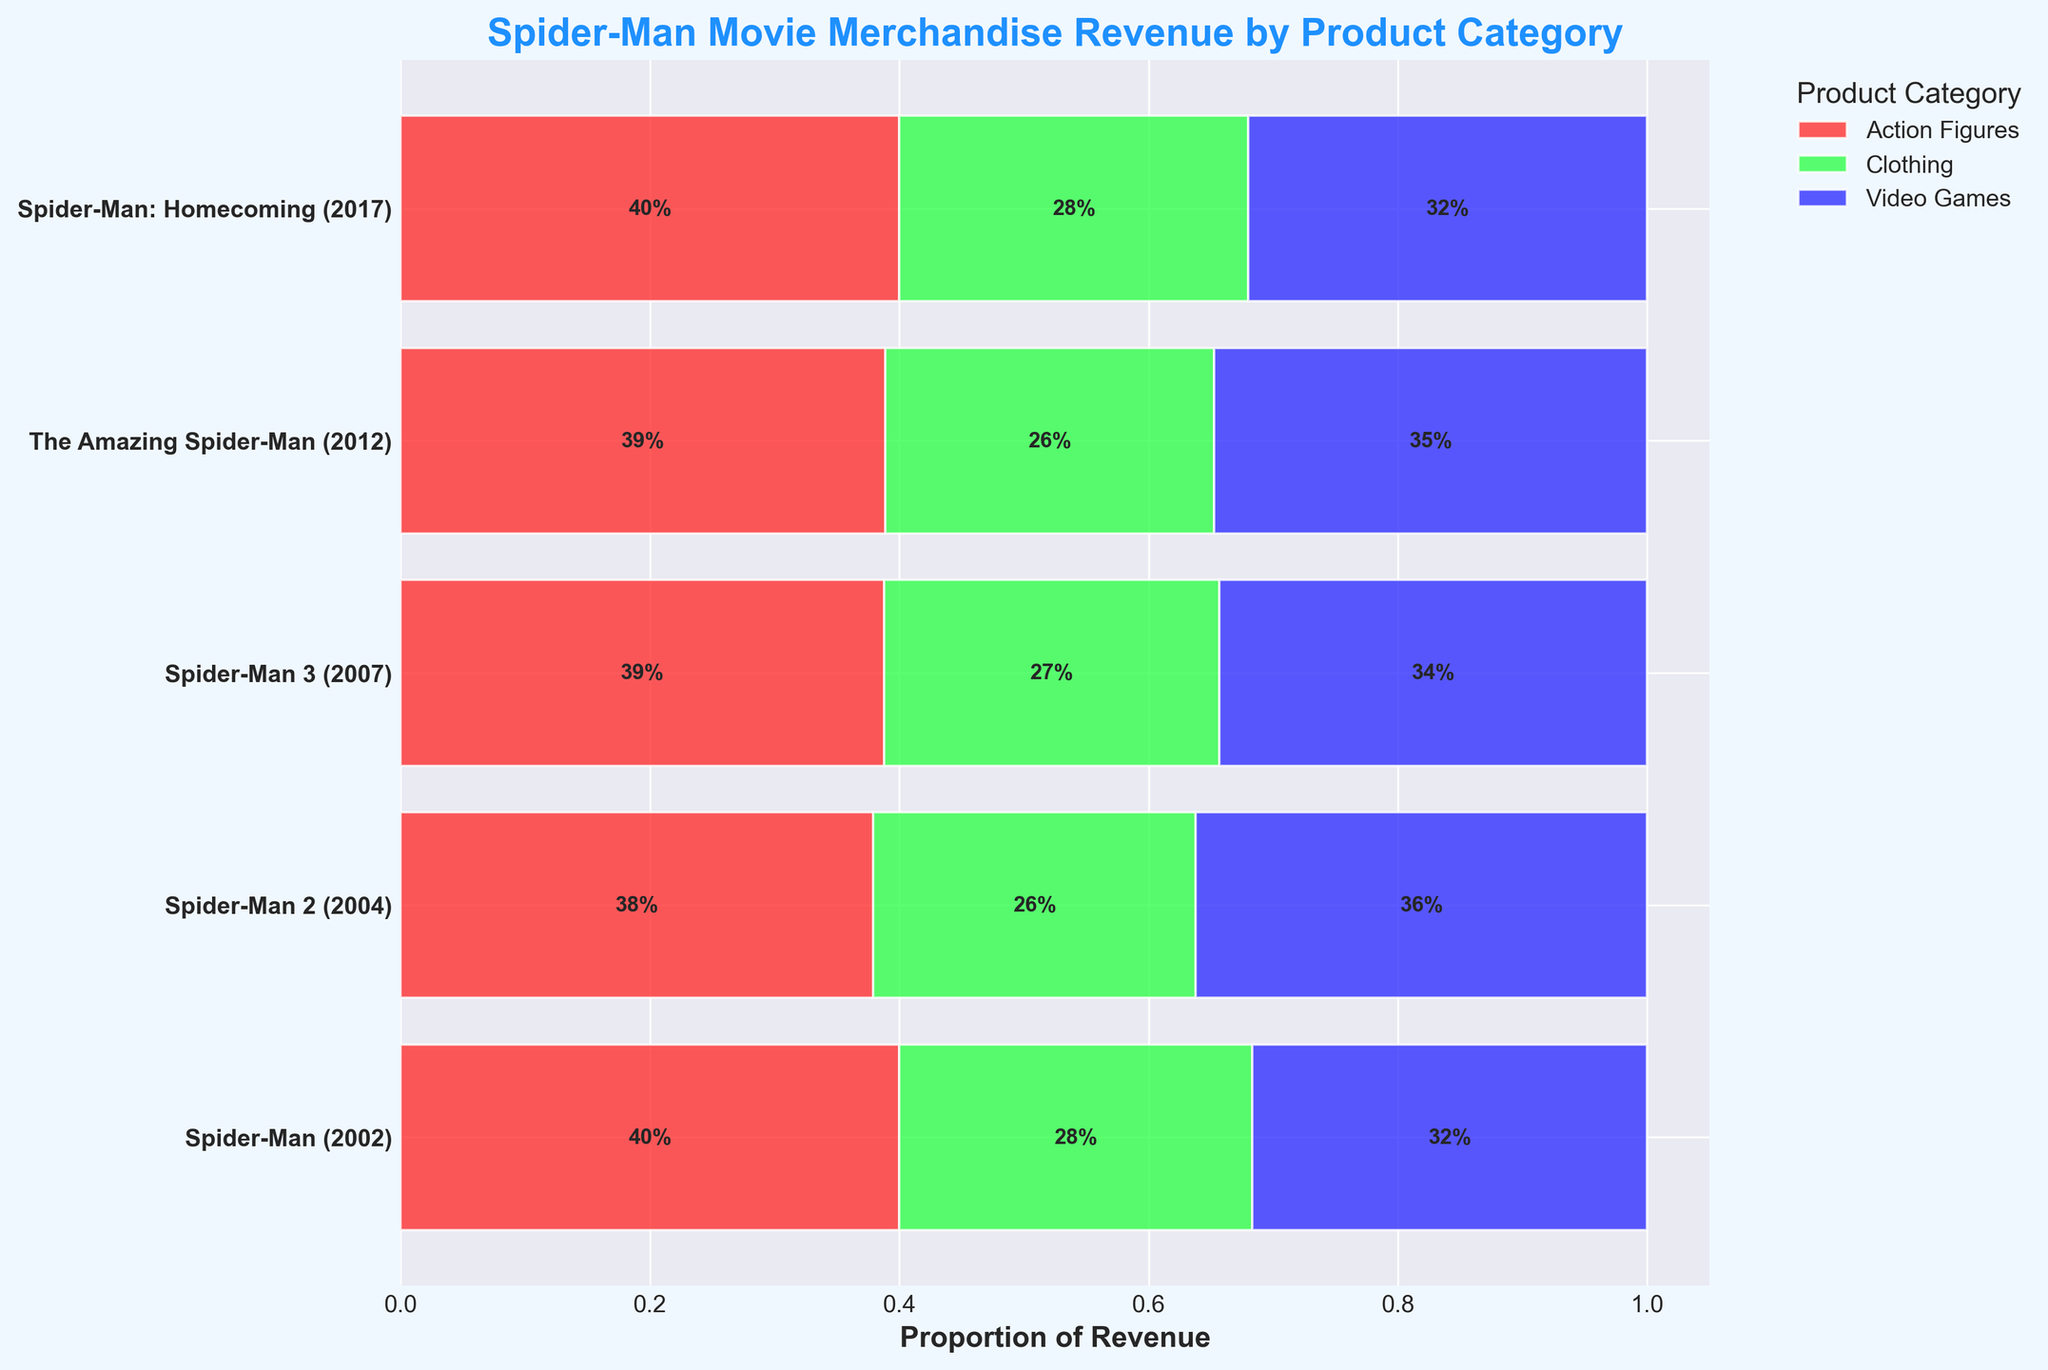What's the title of the plot? The title of the plot is displayed prominently at the top and written in bold blue font.
Answer: Spider-Man Movie Merchandise Revenue by Product Category What categories are compared in the plot? The plot compares different product categories, which are indicated in the legend and visually differentiated by distinct colors: red, green, and blue.
Answer: Action Figures, Clothing, Video Games Which film has the highest proportion of revenue from Action Figures? The plot shows horizontal bars with sections for each category proportionate to their revenue. The film "Spider-Man: Homecoming (2017)" has the largest red section for Action Figures.
Answer: Spider-Man: Homecoming (2017) What is the proportion of Video Games revenue for "Spider-Man 3 (2007)"? Look at the bar for "Spider-Man 3 (2007)" and find the blue section representing Video Games. The proportion label indicates the percentage.
Answer: 31% Which film contributed the least revenue to Clothing? Find the film with the smallest green section in its bar, then confirm this by checking the labels.
Answer: The Amazing Spider-Man (2012) How does the total revenue distribution compare between "Spider-Man (2002)" and "Spider-Man 3 (2007)"? Compare the size of the bars for these two films. Measure the segments by their proportions of Action Figures, Clothing, and Video Games combined.
Answer: "Spider-Man 3 (2007)" has higher proportions in all categories compared to "Spider-Man (2002)" What is the difference in the proportion of Action Figures revenue between "Spider-Man: Homecoming (2017)" and "The Amazing Spider-Man (2012)"? Calculate the difference by subtracting the proportion of Action Figures in "The Amazing Spider-Man (2012)" from that in "Spider-Man: Homecoming (2017)". This requires reading the proportions from the plot.
Answer: 11% Which film has the most balanced distribution of revenue among all product categories? The most balanced distribution will have approximately equal proportions for each category. Compare all the films and their bars to determine the most equal distribution.
Answer: Spider-Man 2 (2004) What's the smallest proportional segment for "Spider-Man: Homecoming (2017)" and which category does it belong to? Identify the smallest segment in the bar for "Spider-Man: Homecoming (2017)" and read the label for that segment.
Answer: Clothing (20%) How does the Clothing revenue proportion for "Spider-Man (2002)" compare to "Spider-Man 2 (2004)"? Look at the proportion labels for Clothing in both films and compare their values.
Answer: "Spider-Man (2002)" has a higher Clothing revenue proportion than "Spider-Man 2 (2004)" 